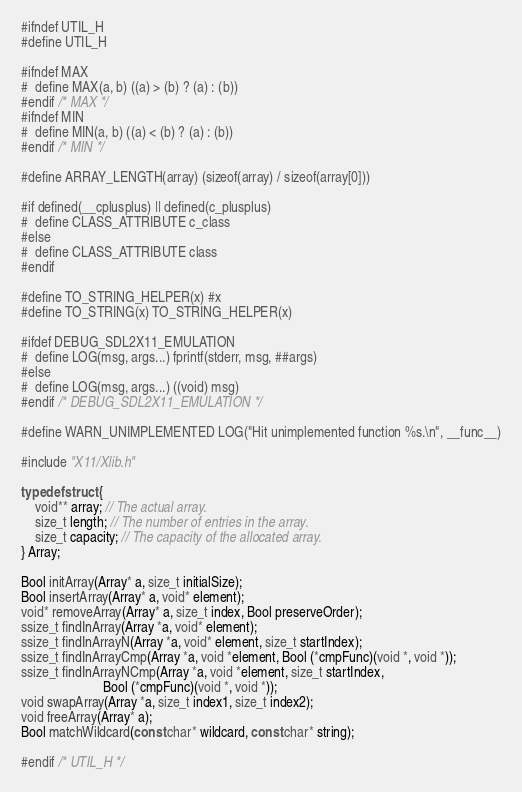<code> <loc_0><loc_0><loc_500><loc_500><_C_>#ifndef UTIL_H
#define UTIL_H

#ifndef MAX
#  define MAX(a, b) ((a) > (b) ? (a) : (b))
#endif /* MAX */
#ifndef MIN
#  define MIN(a, b) ((a) < (b) ? (a) : (b))
#endif /* MIN */

#define ARRAY_LENGTH(array) (sizeof(array) / sizeof(array[0]))

#if defined(__cplusplus) || defined(c_plusplus)
#  define CLASS_ATTRIBUTE c_class
#else
#  define CLASS_ATTRIBUTE class
#endif

#define TO_STRING_HELPER(x) #x
#define TO_STRING(x) TO_STRING_HELPER(x)

#ifdef DEBUG_SDL2X11_EMULATION
#  define LOG(msg, args...) fprintf(stderr, msg, ##args)
#else
#  define LOG(msg, args...) ((void) msg)
#endif /* DEBUG_SDL2X11_EMULATION */

#define WARN_UNIMPLEMENTED LOG("Hit unimplemented function %s.\n", __func__)

#include "X11/Xlib.h"

typedef struct {
    void** array; // The actual array.
    size_t length; // The number of entries in the array.
    size_t capacity; // The capacity of the allocated array.
} Array;

Bool initArray(Array* a, size_t initialSize);
Bool insertArray(Array* a, void* element);
void* removeArray(Array* a, size_t index, Bool preserveOrder);
ssize_t findInArray(Array *a, void* element);
ssize_t findInArrayN(Array *a, void* element, size_t startIndex);
ssize_t findInArrayCmp(Array *a, void *element, Bool (*cmpFunc)(void *, void *));
ssize_t findInArrayNCmp(Array *a, void *element, size_t startIndex,
                        Bool (*cmpFunc)(void *, void *));
void swapArray(Array *a, size_t index1, size_t index2);
void freeArray(Array* a);
Bool matchWildcard(const char* wildcard, const char* string);

#endif /* UTIL_H */
</code> 